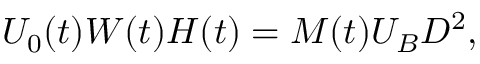<formula> <loc_0><loc_0><loc_500><loc_500>U _ { 0 } ( t ) W ( t ) H ( t ) = M ( t ) U _ { B } D ^ { 2 } ,</formula> 